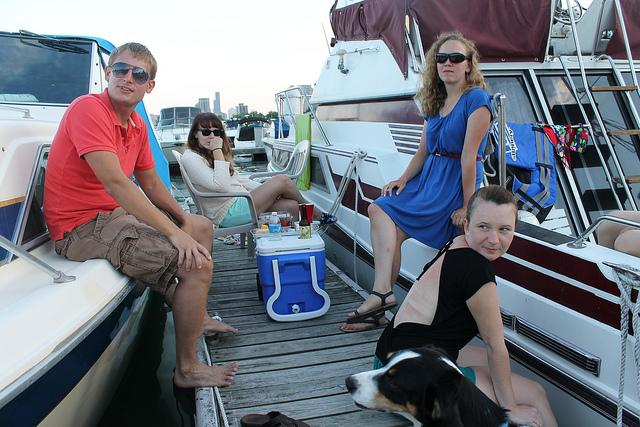Clothing items are hung here for which purpose? Please explain your reasoning. drying. These items are on a boat and by water where they can get wet. the sun is out and it is a hot day to hanging them over the side of the boat would dry them in the air. 